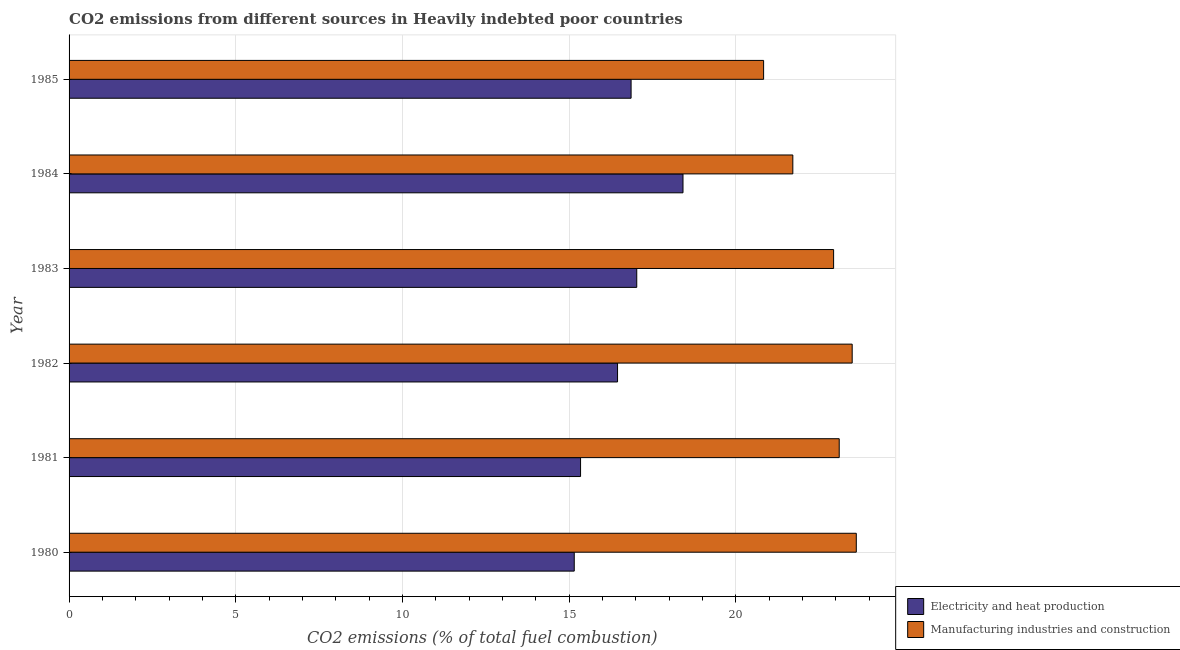How many different coloured bars are there?
Your answer should be compact. 2. Are the number of bars per tick equal to the number of legend labels?
Your answer should be very brief. Yes. Are the number of bars on each tick of the Y-axis equal?
Your answer should be compact. Yes. What is the label of the 6th group of bars from the top?
Provide a succinct answer. 1980. In how many cases, is the number of bars for a given year not equal to the number of legend labels?
Give a very brief answer. 0. What is the co2 emissions due to manufacturing industries in 1980?
Provide a short and direct response. 23.62. Across all years, what is the maximum co2 emissions due to manufacturing industries?
Provide a succinct answer. 23.62. Across all years, what is the minimum co2 emissions due to manufacturing industries?
Your answer should be very brief. 20.84. In which year was the co2 emissions due to electricity and heat production minimum?
Your response must be concise. 1980. What is the total co2 emissions due to electricity and heat production in the graph?
Give a very brief answer. 99.26. What is the difference between the co2 emissions due to electricity and heat production in 1983 and that in 1985?
Offer a terse response. 0.17. What is the difference between the co2 emissions due to manufacturing industries in 1981 and the co2 emissions due to electricity and heat production in 1980?
Your answer should be compact. 7.95. What is the average co2 emissions due to electricity and heat production per year?
Your response must be concise. 16.54. In the year 1982, what is the difference between the co2 emissions due to manufacturing industries and co2 emissions due to electricity and heat production?
Provide a succinct answer. 7.04. In how many years, is the co2 emissions due to manufacturing industries greater than 7 %?
Your answer should be compact. 6. What is the ratio of the co2 emissions due to manufacturing industries in 1982 to that in 1985?
Your answer should be very brief. 1.13. Is the co2 emissions due to manufacturing industries in 1982 less than that in 1984?
Offer a very short reply. No. What is the difference between the highest and the second highest co2 emissions due to manufacturing industries?
Keep it short and to the point. 0.12. What is the difference between the highest and the lowest co2 emissions due to manufacturing industries?
Provide a short and direct response. 2.78. What does the 1st bar from the top in 1982 represents?
Your answer should be very brief. Manufacturing industries and construction. What does the 1st bar from the bottom in 1983 represents?
Give a very brief answer. Electricity and heat production. How many years are there in the graph?
Offer a very short reply. 6. What is the difference between two consecutive major ticks on the X-axis?
Give a very brief answer. 5. How are the legend labels stacked?
Offer a very short reply. Vertical. What is the title of the graph?
Offer a terse response. CO2 emissions from different sources in Heavily indebted poor countries. Does "Rural" appear as one of the legend labels in the graph?
Your response must be concise. No. What is the label or title of the X-axis?
Offer a terse response. CO2 emissions (% of total fuel combustion). What is the CO2 emissions (% of total fuel combustion) in Electricity and heat production in 1980?
Your response must be concise. 15.16. What is the CO2 emissions (% of total fuel combustion) in Manufacturing industries and construction in 1980?
Keep it short and to the point. 23.62. What is the CO2 emissions (% of total fuel combustion) of Electricity and heat production in 1981?
Your response must be concise. 15.34. What is the CO2 emissions (% of total fuel combustion) of Manufacturing industries and construction in 1981?
Offer a terse response. 23.1. What is the CO2 emissions (% of total fuel combustion) of Electricity and heat production in 1982?
Offer a very short reply. 16.45. What is the CO2 emissions (% of total fuel combustion) of Manufacturing industries and construction in 1982?
Your response must be concise. 23.49. What is the CO2 emissions (% of total fuel combustion) of Electricity and heat production in 1983?
Your response must be concise. 17.03. What is the CO2 emissions (% of total fuel combustion) of Manufacturing industries and construction in 1983?
Offer a very short reply. 22.94. What is the CO2 emissions (% of total fuel combustion) of Electricity and heat production in 1984?
Offer a very short reply. 18.42. What is the CO2 emissions (% of total fuel combustion) of Manufacturing industries and construction in 1984?
Your answer should be very brief. 21.71. What is the CO2 emissions (% of total fuel combustion) in Electricity and heat production in 1985?
Your answer should be compact. 16.86. What is the CO2 emissions (% of total fuel combustion) in Manufacturing industries and construction in 1985?
Provide a short and direct response. 20.84. Across all years, what is the maximum CO2 emissions (% of total fuel combustion) of Electricity and heat production?
Offer a terse response. 18.42. Across all years, what is the maximum CO2 emissions (% of total fuel combustion) in Manufacturing industries and construction?
Provide a short and direct response. 23.62. Across all years, what is the minimum CO2 emissions (% of total fuel combustion) in Electricity and heat production?
Ensure brevity in your answer.  15.16. Across all years, what is the minimum CO2 emissions (% of total fuel combustion) in Manufacturing industries and construction?
Provide a succinct answer. 20.84. What is the total CO2 emissions (% of total fuel combustion) in Electricity and heat production in the graph?
Give a very brief answer. 99.26. What is the total CO2 emissions (% of total fuel combustion) in Manufacturing industries and construction in the graph?
Offer a terse response. 135.7. What is the difference between the CO2 emissions (% of total fuel combustion) of Electricity and heat production in 1980 and that in 1981?
Ensure brevity in your answer.  -0.19. What is the difference between the CO2 emissions (% of total fuel combustion) of Manufacturing industries and construction in 1980 and that in 1981?
Give a very brief answer. 0.51. What is the difference between the CO2 emissions (% of total fuel combustion) in Electricity and heat production in 1980 and that in 1982?
Make the answer very short. -1.3. What is the difference between the CO2 emissions (% of total fuel combustion) of Manufacturing industries and construction in 1980 and that in 1982?
Ensure brevity in your answer.  0.12. What is the difference between the CO2 emissions (% of total fuel combustion) in Electricity and heat production in 1980 and that in 1983?
Your answer should be compact. -1.87. What is the difference between the CO2 emissions (% of total fuel combustion) of Manufacturing industries and construction in 1980 and that in 1983?
Give a very brief answer. 0.68. What is the difference between the CO2 emissions (% of total fuel combustion) of Electricity and heat production in 1980 and that in 1984?
Ensure brevity in your answer.  -3.26. What is the difference between the CO2 emissions (% of total fuel combustion) in Manufacturing industries and construction in 1980 and that in 1984?
Your answer should be compact. 1.9. What is the difference between the CO2 emissions (% of total fuel combustion) of Electricity and heat production in 1980 and that in 1985?
Keep it short and to the point. -1.71. What is the difference between the CO2 emissions (% of total fuel combustion) in Manufacturing industries and construction in 1980 and that in 1985?
Your response must be concise. 2.78. What is the difference between the CO2 emissions (% of total fuel combustion) in Electricity and heat production in 1981 and that in 1982?
Give a very brief answer. -1.11. What is the difference between the CO2 emissions (% of total fuel combustion) of Manufacturing industries and construction in 1981 and that in 1982?
Provide a succinct answer. -0.39. What is the difference between the CO2 emissions (% of total fuel combustion) of Electricity and heat production in 1981 and that in 1983?
Offer a very short reply. -1.69. What is the difference between the CO2 emissions (% of total fuel combustion) of Manufacturing industries and construction in 1981 and that in 1983?
Provide a succinct answer. 0.17. What is the difference between the CO2 emissions (% of total fuel combustion) of Electricity and heat production in 1981 and that in 1984?
Offer a very short reply. -3.07. What is the difference between the CO2 emissions (% of total fuel combustion) of Manufacturing industries and construction in 1981 and that in 1984?
Provide a short and direct response. 1.39. What is the difference between the CO2 emissions (% of total fuel combustion) in Electricity and heat production in 1981 and that in 1985?
Provide a succinct answer. -1.52. What is the difference between the CO2 emissions (% of total fuel combustion) of Manufacturing industries and construction in 1981 and that in 1985?
Your answer should be compact. 2.27. What is the difference between the CO2 emissions (% of total fuel combustion) of Electricity and heat production in 1982 and that in 1983?
Provide a succinct answer. -0.58. What is the difference between the CO2 emissions (% of total fuel combustion) in Manufacturing industries and construction in 1982 and that in 1983?
Your answer should be compact. 0.56. What is the difference between the CO2 emissions (% of total fuel combustion) of Electricity and heat production in 1982 and that in 1984?
Ensure brevity in your answer.  -1.96. What is the difference between the CO2 emissions (% of total fuel combustion) in Manufacturing industries and construction in 1982 and that in 1984?
Your response must be concise. 1.78. What is the difference between the CO2 emissions (% of total fuel combustion) of Electricity and heat production in 1982 and that in 1985?
Give a very brief answer. -0.41. What is the difference between the CO2 emissions (% of total fuel combustion) of Manufacturing industries and construction in 1982 and that in 1985?
Offer a very short reply. 2.66. What is the difference between the CO2 emissions (% of total fuel combustion) of Electricity and heat production in 1983 and that in 1984?
Your answer should be compact. -1.39. What is the difference between the CO2 emissions (% of total fuel combustion) of Manufacturing industries and construction in 1983 and that in 1984?
Your response must be concise. 1.22. What is the difference between the CO2 emissions (% of total fuel combustion) in Electricity and heat production in 1983 and that in 1985?
Make the answer very short. 0.17. What is the difference between the CO2 emissions (% of total fuel combustion) in Manufacturing industries and construction in 1983 and that in 1985?
Make the answer very short. 2.1. What is the difference between the CO2 emissions (% of total fuel combustion) of Electricity and heat production in 1984 and that in 1985?
Your response must be concise. 1.56. What is the difference between the CO2 emissions (% of total fuel combustion) of Manufacturing industries and construction in 1984 and that in 1985?
Your answer should be compact. 0.88. What is the difference between the CO2 emissions (% of total fuel combustion) of Electricity and heat production in 1980 and the CO2 emissions (% of total fuel combustion) of Manufacturing industries and construction in 1981?
Provide a short and direct response. -7.95. What is the difference between the CO2 emissions (% of total fuel combustion) in Electricity and heat production in 1980 and the CO2 emissions (% of total fuel combustion) in Manufacturing industries and construction in 1982?
Your response must be concise. -8.34. What is the difference between the CO2 emissions (% of total fuel combustion) of Electricity and heat production in 1980 and the CO2 emissions (% of total fuel combustion) of Manufacturing industries and construction in 1983?
Offer a terse response. -7.78. What is the difference between the CO2 emissions (% of total fuel combustion) in Electricity and heat production in 1980 and the CO2 emissions (% of total fuel combustion) in Manufacturing industries and construction in 1984?
Your response must be concise. -6.56. What is the difference between the CO2 emissions (% of total fuel combustion) in Electricity and heat production in 1980 and the CO2 emissions (% of total fuel combustion) in Manufacturing industries and construction in 1985?
Provide a short and direct response. -5.68. What is the difference between the CO2 emissions (% of total fuel combustion) of Electricity and heat production in 1981 and the CO2 emissions (% of total fuel combustion) of Manufacturing industries and construction in 1982?
Your response must be concise. -8.15. What is the difference between the CO2 emissions (% of total fuel combustion) in Electricity and heat production in 1981 and the CO2 emissions (% of total fuel combustion) in Manufacturing industries and construction in 1983?
Your answer should be compact. -7.59. What is the difference between the CO2 emissions (% of total fuel combustion) of Electricity and heat production in 1981 and the CO2 emissions (% of total fuel combustion) of Manufacturing industries and construction in 1984?
Make the answer very short. -6.37. What is the difference between the CO2 emissions (% of total fuel combustion) of Electricity and heat production in 1981 and the CO2 emissions (% of total fuel combustion) of Manufacturing industries and construction in 1985?
Offer a terse response. -5.49. What is the difference between the CO2 emissions (% of total fuel combustion) in Electricity and heat production in 1982 and the CO2 emissions (% of total fuel combustion) in Manufacturing industries and construction in 1983?
Make the answer very short. -6.48. What is the difference between the CO2 emissions (% of total fuel combustion) in Electricity and heat production in 1982 and the CO2 emissions (% of total fuel combustion) in Manufacturing industries and construction in 1984?
Give a very brief answer. -5.26. What is the difference between the CO2 emissions (% of total fuel combustion) of Electricity and heat production in 1982 and the CO2 emissions (% of total fuel combustion) of Manufacturing industries and construction in 1985?
Your answer should be very brief. -4.38. What is the difference between the CO2 emissions (% of total fuel combustion) in Electricity and heat production in 1983 and the CO2 emissions (% of total fuel combustion) in Manufacturing industries and construction in 1984?
Provide a succinct answer. -4.68. What is the difference between the CO2 emissions (% of total fuel combustion) in Electricity and heat production in 1983 and the CO2 emissions (% of total fuel combustion) in Manufacturing industries and construction in 1985?
Offer a terse response. -3.81. What is the difference between the CO2 emissions (% of total fuel combustion) of Electricity and heat production in 1984 and the CO2 emissions (% of total fuel combustion) of Manufacturing industries and construction in 1985?
Keep it short and to the point. -2.42. What is the average CO2 emissions (% of total fuel combustion) in Electricity and heat production per year?
Make the answer very short. 16.54. What is the average CO2 emissions (% of total fuel combustion) of Manufacturing industries and construction per year?
Your answer should be compact. 22.62. In the year 1980, what is the difference between the CO2 emissions (% of total fuel combustion) in Electricity and heat production and CO2 emissions (% of total fuel combustion) in Manufacturing industries and construction?
Provide a succinct answer. -8.46. In the year 1981, what is the difference between the CO2 emissions (% of total fuel combustion) of Electricity and heat production and CO2 emissions (% of total fuel combustion) of Manufacturing industries and construction?
Your response must be concise. -7.76. In the year 1982, what is the difference between the CO2 emissions (% of total fuel combustion) in Electricity and heat production and CO2 emissions (% of total fuel combustion) in Manufacturing industries and construction?
Provide a succinct answer. -7.04. In the year 1983, what is the difference between the CO2 emissions (% of total fuel combustion) in Electricity and heat production and CO2 emissions (% of total fuel combustion) in Manufacturing industries and construction?
Your response must be concise. -5.91. In the year 1984, what is the difference between the CO2 emissions (% of total fuel combustion) of Electricity and heat production and CO2 emissions (% of total fuel combustion) of Manufacturing industries and construction?
Your response must be concise. -3.3. In the year 1985, what is the difference between the CO2 emissions (% of total fuel combustion) in Electricity and heat production and CO2 emissions (% of total fuel combustion) in Manufacturing industries and construction?
Make the answer very short. -3.98. What is the ratio of the CO2 emissions (% of total fuel combustion) in Electricity and heat production in 1980 to that in 1981?
Your response must be concise. 0.99. What is the ratio of the CO2 emissions (% of total fuel combustion) of Manufacturing industries and construction in 1980 to that in 1981?
Keep it short and to the point. 1.02. What is the ratio of the CO2 emissions (% of total fuel combustion) in Electricity and heat production in 1980 to that in 1982?
Provide a succinct answer. 0.92. What is the ratio of the CO2 emissions (% of total fuel combustion) in Manufacturing industries and construction in 1980 to that in 1982?
Your answer should be compact. 1.01. What is the ratio of the CO2 emissions (% of total fuel combustion) of Electricity and heat production in 1980 to that in 1983?
Your answer should be very brief. 0.89. What is the ratio of the CO2 emissions (% of total fuel combustion) in Manufacturing industries and construction in 1980 to that in 1983?
Make the answer very short. 1.03. What is the ratio of the CO2 emissions (% of total fuel combustion) of Electricity and heat production in 1980 to that in 1984?
Provide a short and direct response. 0.82. What is the ratio of the CO2 emissions (% of total fuel combustion) of Manufacturing industries and construction in 1980 to that in 1984?
Keep it short and to the point. 1.09. What is the ratio of the CO2 emissions (% of total fuel combustion) in Electricity and heat production in 1980 to that in 1985?
Offer a terse response. 0.9. What is the ratio of the CO2 emissions (% of total fuel combustion) in Manufacturing industries and construction in 1980 to that in 1985?
Your response must be concise. 1.13. What is the ratio of the CO2 emissions (% of total fuel combustion) of Electricity and heat production in 1981 to that in 1982?
Your answer should be compact. 0.93. What is the ratio of the CO2 emissions (% of total fuel combustion) of Manufacturing industries and construction in 1981 to that in 1982?
Your answer should be very brief. 0.98. What is the ratio of the CO2 emissions (% of total fuel combustion) of Electricity and heat production in 1981 to that in 1983?
Make the answer very short. 0.9. What is the ratio of the CO2 emissions (% of total fuel combustion) of Manufacturing industries and construction in 1981 to that in 1983?
Offer a terse response. 1.01. What is the ratio of the CO2 emissions (% of total fuel combustion) in Electricity and heat production in 1981 to that in 1984?
Make the answer very short. 0.83. What is the ratio of the CO2 emissions (% of total fuel combustion) in Manufacturing industries and construction in 1981 to that in 1984?
Your answer should be very brief. 1.06. What is the ratio of the CO2 emissions (% of total fuel combustion) in Electricity and heat production in 1981 to that in 1985?
Your answer should be compact. 0.91. What is the ratio of the CO2 emissions (% of total fuel combustion) of Manufacturing industries and construction in 1981 to that in 1985?
Your response must be concise. 1.11. What is the ratio of the CO2 emissions (% of total fuel combustion) in Electricity and heat production in 1982 to that in 1983?
Your answer should be compact. 0.97. What is the ratio of the CO2 emissions (% of total fuel combustion) in Manufacturing industries and construction in 1982 to that in 1983?
Keep it short and to the point. 1.02. What is the ratio of the CO2 emissions (% of total fuel combustion) in Electricity and heat production in 1982 to that in 1984?
Offer a terse response. 0.89. What is the ratio of the CO2 emissions (% of total fuel combustion) of Manufacturing industries and construction in 1982 to that in 1984?
Ensure brevity in your answer.  1.08. What is the ratio of the CO2 emissions (% of total fuel combustion) in Electricity and heat production in 1982 to that in 1985?
Offer a very short reply. 0.98. What is the ratio of the CO2 emissions (% of total fuel combustion) in Manufacturing industries and construction in 1982 to that in 1985?
Your answer should be compact. 1.13. What is the ratio of the CO2 emissions (% of total fuel combustion) in Electricity and heat production in 1983 to that in 1984?
Provide a short and direct response. 0.92. What is the ratio of the CO2 emissions (% of total fuel combustion) in Manufacturing industries and construction in 1983 to that in 1984?
Your response must be concise. 1.06. What is the ratio of the CO2 emissions (% of total fuel combustion) of Manufacturing industries and construction in 1983 to that in 1985?
Keep it short and to the point. 1.1. What is the ratio of the CO2 emissions (% of total fuel combustion) of Electricity and heat production in 1984 to that in 1985?
Provide a short and direct response. 1.09. What is the ratio of the CO2 emissions (% of total fuel combustion) of Manufacturing industries and construction in 1984 to that in 1985?
Keep it short and to the point. 1.04. What is the difference between the highest and the second highest CO2 emissions (% of total fuel combustion) of Electricity and heat production?
Give a very brief answer. 1.39. What is the difference between the highest and the second highest CO2 emissions (% of total fuel combustion) of Manufacturing industries and construction?
Offer a very short reply. 0.12. What is the difference between the highest and the lowest CO2 emissions (% of total fuel combustion) in Electricity and heat production?
Your answer should be very brief. 3.26. What is the difference between the highest and the lowest CO2 emissions (% of total fuel combustion) of Manufacturing industries and construction?
Provide a short and direct response. 2.78. 